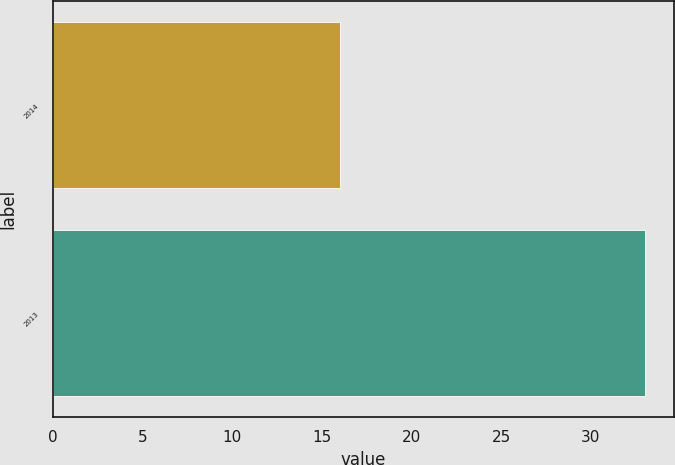Convert chart. <chart><loc_0><loc_0><loc_500><loc_500><bar_chart><fcel>2014<fcel>2013<nl><fcel>16<fcel>33<nl></chart> 